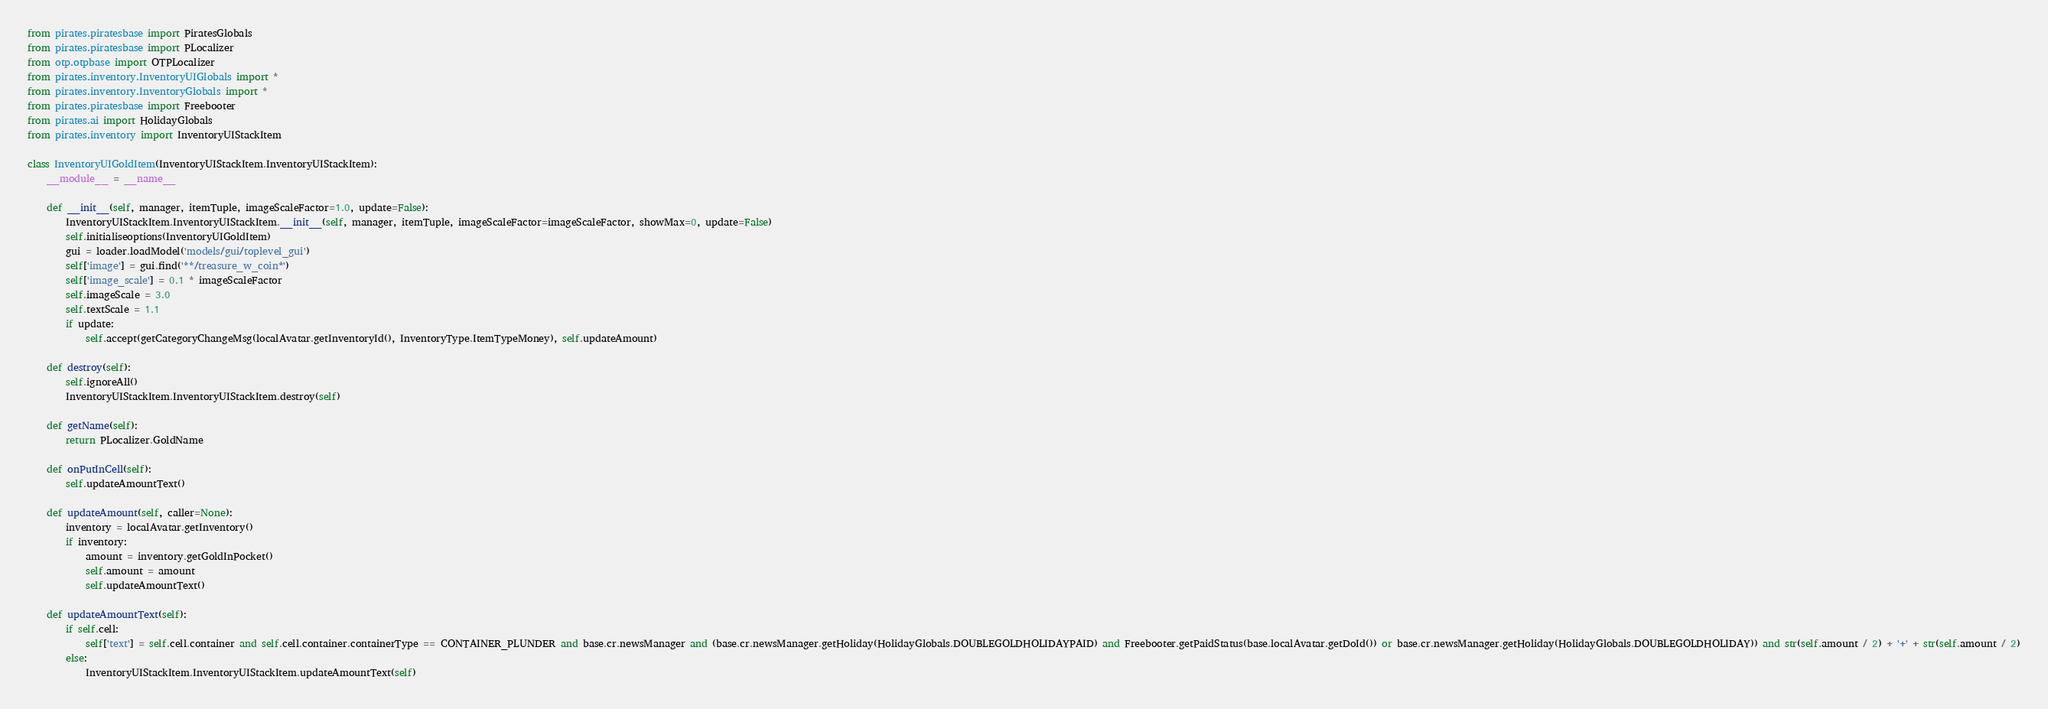Convert code to text. <code><loc_0><loc_0><loc_500><loc_500><_Python_>from pirates.piratesbase import PiratesGlobals
from pirates.piratesbase import PLocalizer
from otp.otpbase import OTPLocalizer
from pirates.inventory.InventoryUIGlobals import *
from pirates.inventory.InventoryGlobals import *
from pirates.piratesbase import Freebooter
from pirates.ai import HolidayGlobals
from pirates.inventory import InventoryUIStackItem

class InventoryUIGoldItem(InventoryUIStackItem.InventoryUIStackItem):
    __module__ = __name__

    def __init__(self, manager, itemTuple, imageScaleFactor=1.0, update=False):
        InventoryUIStackItem.InventoryUIStackItem.__init__(self, manager, itemTuple, imageScaleFactor=imageScaleFactor, showMax=0, update=False)
        self.initialiseoptions(InventoryUIGoldItem)
        gui = loader.loadModel('models/gui/toplevel_gui')
        self['image'] = gui.find('**/treasure_w_coin*')
        self['image_scale'] = 0.1 * imageScaleFactor
        self.imageScale = 3.0
        self.textScale = 1.1
        if update:
            self.accept(getCategoryChangeMsg(localAvatar.getInventoryId(), InventoryType.ItemTypeMoney), self.updateAmount)

    def destroy(self):
        self.ignoreAll()
        InventoryUIStackItem.InventoryUIStackItem.destroy(self)

    def getName(self):
        return PLocalizer.GoldName

    def onPutInCell(self):
        self.updateAmountText()

    def updateAmount(self, caller=None):
        inventory = localAvatar.getInventory()
        if inventory:
            amount = inventory.getGoldInPocket()
            self.amount = amount
            self.updateAmountText()

    def updateAmountText(self):
        if self.cell:
            self['text'] = self.cell.container and self.cell.container.containerType == CONTAINER_PLUNDER and base.cr.newsManager and (base.cr.newsManager.getHoliday(HolidayGlobals.DOUBLEGOLDHOLIDAYPAID) and Freebooter.getPaidStatus(base.localAvatar.getDoId()) or base.cr.newsManager.getHoliday(HolidayGlobals.DOUBLEGOLDHOLIDAY)) and str(self.amount / 2) + '+' + str(self.amount / 2)
        else:
            InventoryUIStackItem.InventoryUIStackItem.updateAmountText(self)</code> 